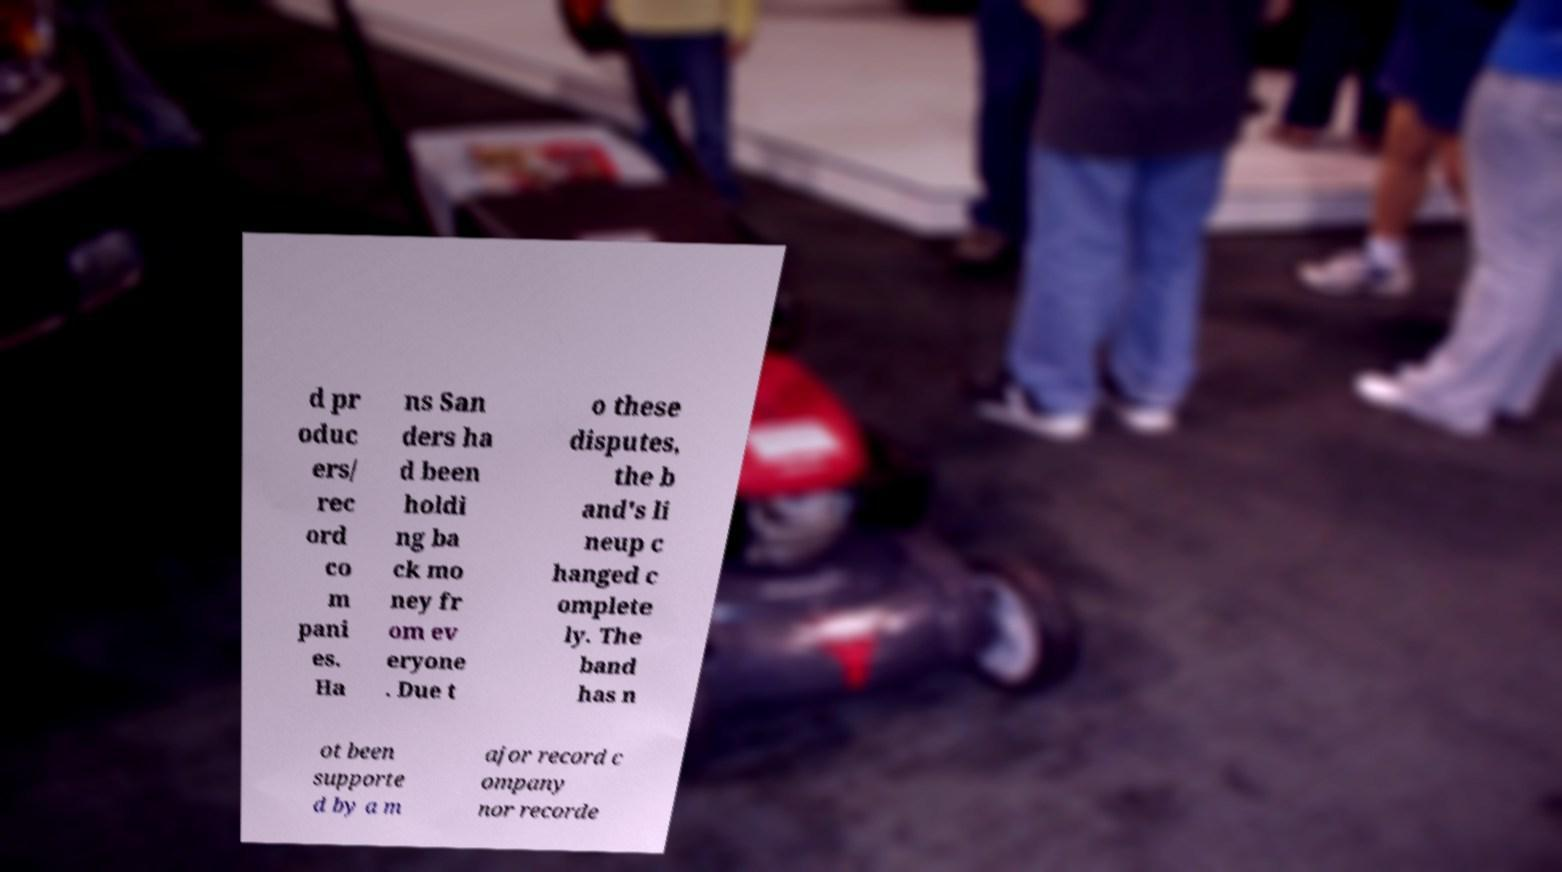For documentation purposes, I need the text within this image transcribed. Could you provide that? d pr oduc ers/ rec ord co m pani es. Ha ns San ders ha d been holdi ng ba ck mo ney fr om ev eryone . Due t o these disputes, the b and's li neup c hanged c omplete ly. The band has n ot been supporte d by a m ajor record c ompany nor recorde 